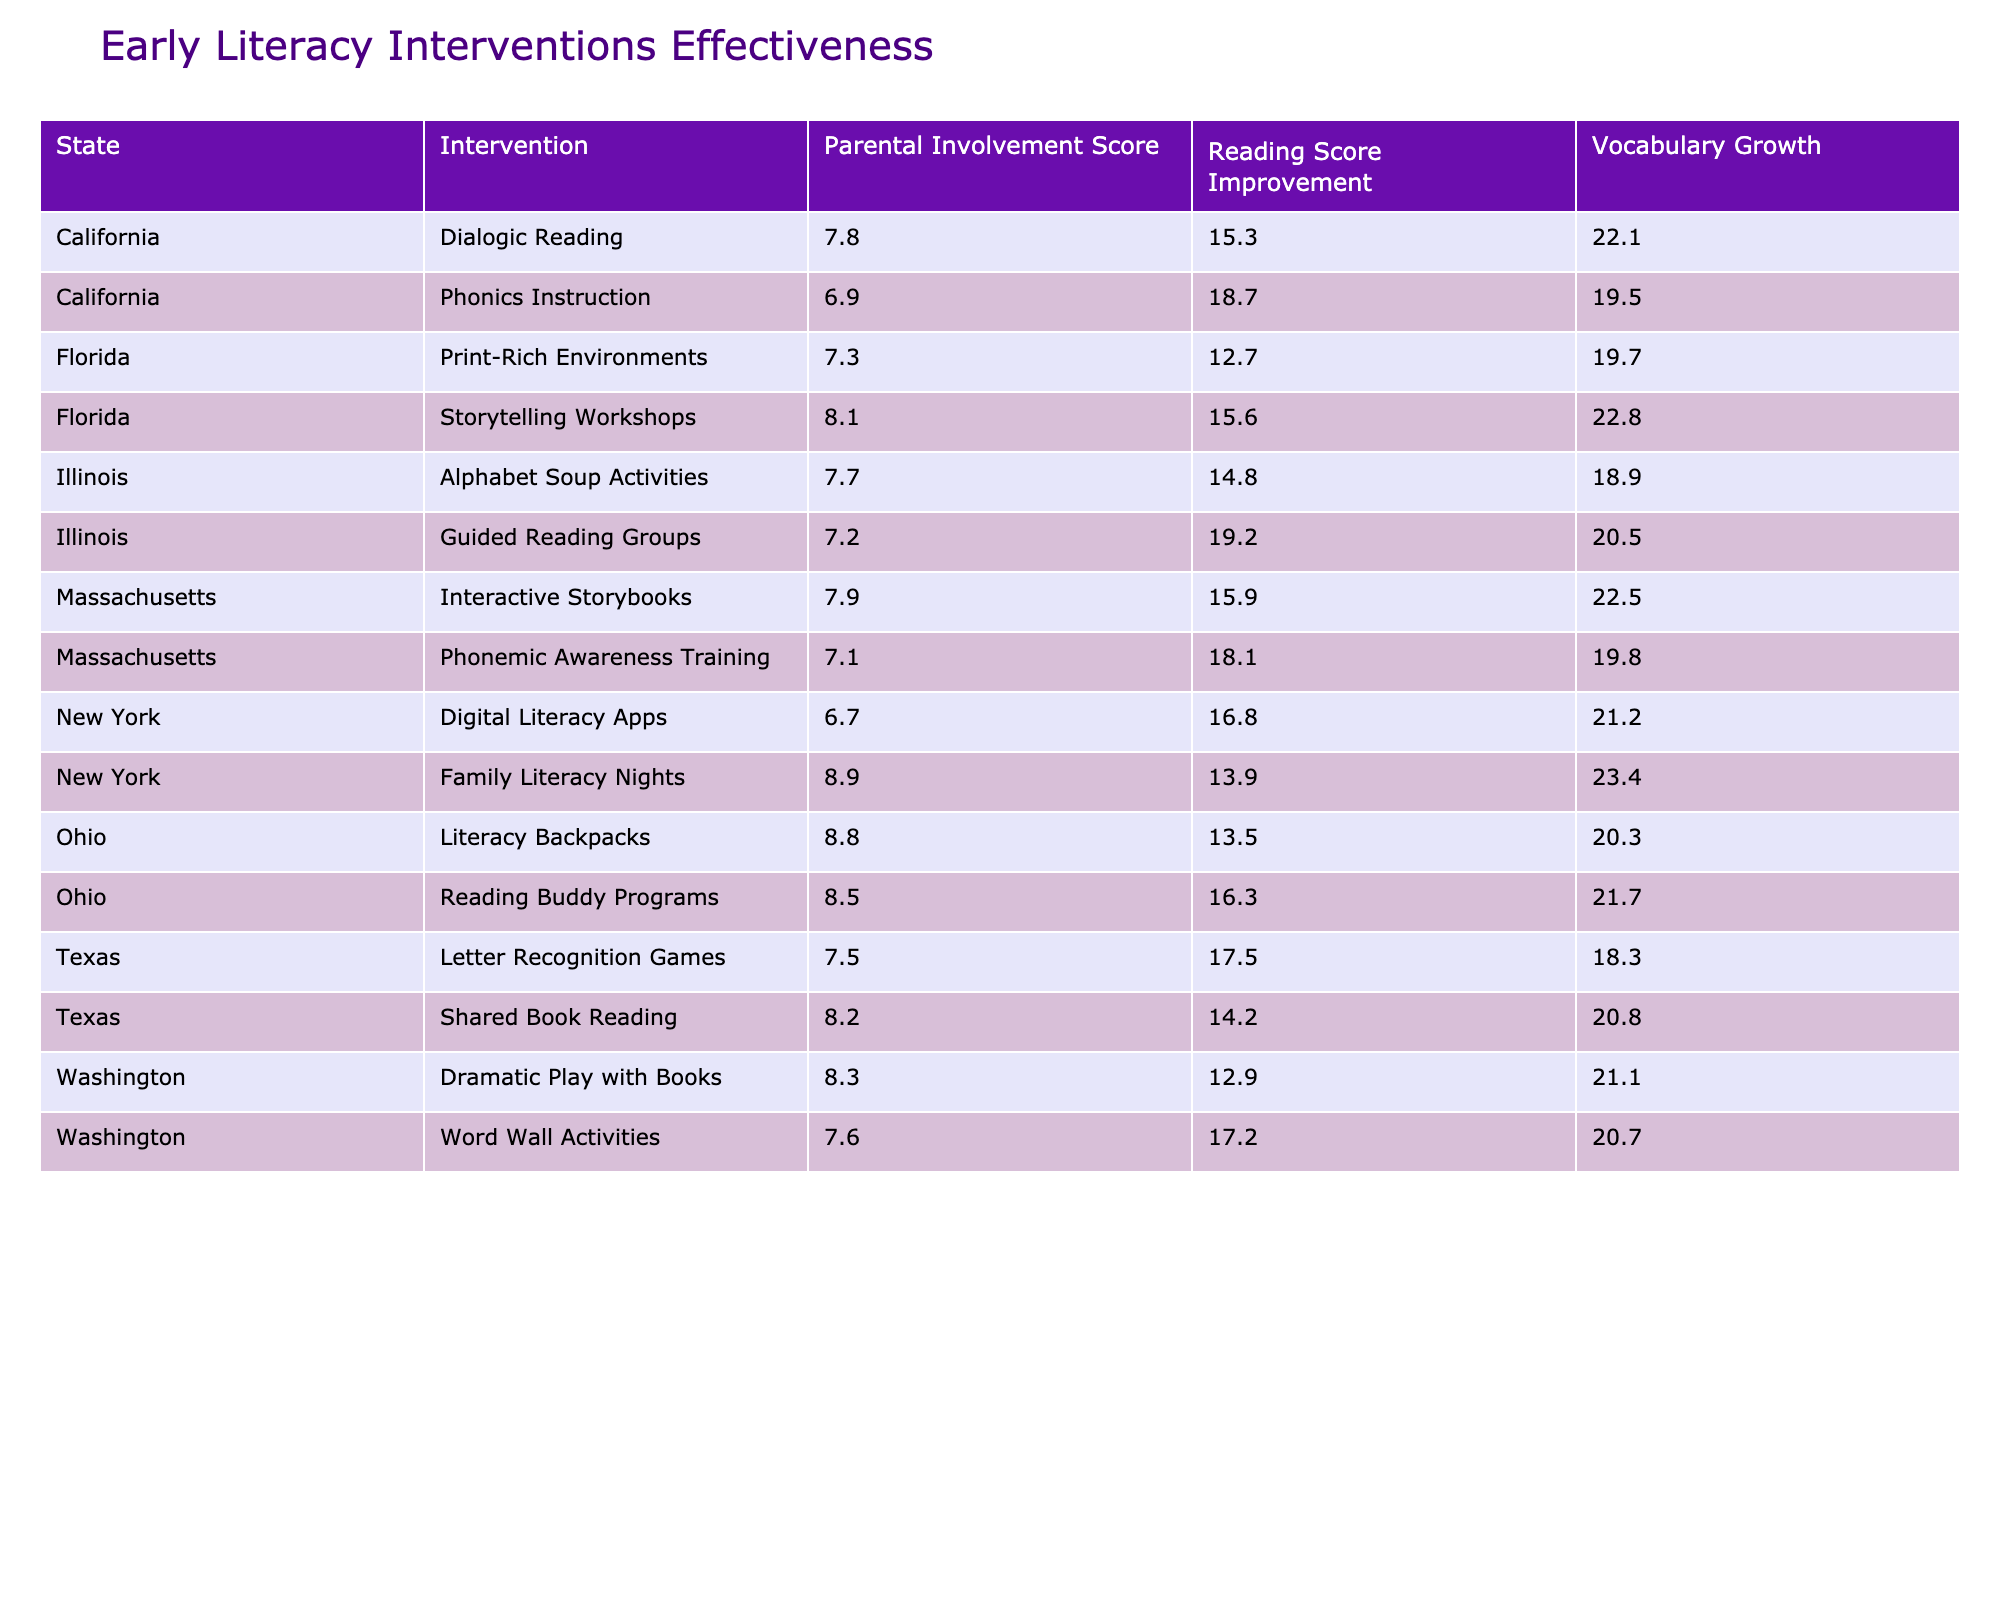What intervention in California had the highest Reading Score Improvement? The Reading Score Improvement for each intervention in California is as follows: Dialogic Reading - 15.3 and Phonics Instruction - 18.7. The highest value is 18.7 for Phonics Instruction.
Answer: Phonics Instruction Which state had the lowest average Vocabulary Growth across all interventions? To find the state with the lowest average Vocabulary Growth, we calculate the average Vocabulary Growth for each state: California (20.8), Texas (19.5), New York (22.3), Florida (21.3), Illinois (19.7), Ohio (20.1), Massachusetts (21.9), and Washington (20.9). The lowest average is 19.5 in Texas.
Answer: Texas Is the Parental Involvement Score for Digital Literacy Apps in New York higher than the score for Family Literacy Nights in the same state? The Parental Involvement Score for Digital Literacy Apps is 6.7, and for Family Literacy Nights, it is 8.9. Since 6.7 is less than 8.9, the statement is false.
Answer: No What is the average Reading Score Improvement of interventions for the age group 2-4 years across all states? The Reading Score Improvements for the 2-4 years age group are: Texas - 14.2, Florida - 12.7, Ohio - 13.5, and Washington - 12.9. Summing these gives 53.3, and dividing by 4 yields an average of 13.325.
Answer: 13.325 Which intervention yielded the most improvement in Reading Scores in Illinois? In Illinois, the two interventions are Guided Reading Groups with a score improvement of 19.2 and Alphabet Soup Activities with a score of 14.8. Guided Reading Groups had the highest improvement at 19.2.
Answer: Guided Reading Groups What is the difference in Vocabulary Growth between Storytelling Workshops in Florida and Letter Recognition Games in Texas? The Vocabulary Growth for Storytelling Workshops is 22.8 and for Letter Recognition Games is 18.3. The difference is 22.8 - 18.3 = 4.5.
Answer: 4.5 Which state had interventions that consistently scored higher than 15 in Reading Score Improvement? We check each state: California had scores of 15.3 and 18.7, Texas had 14.2 and 17.5, New York had 16.8 and 13.9, Florida had 12.7 and 15.6, Illinois had 19.2 and 14.8, Ohio had 16.3 and 13.5, Massachusetts had 15.9 and 18.1, and Washington had 12.9 and 17.2. Only California and Illinois had scores consistently above 15.
Answer: California and Illinois What is the highest Parental Involvement Score recorded in the table? By reviewing the Parental Involvement Scores, we have: 7.8 (California, Dialogic Reading), 6.9 (California, Phonics Instruction), 8.2 (Texas, Shared Book Reading), and so on. The highest score is 8.9 from New York's Family Literacy Nights.
Answer: 8.9 